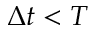<formula> <loc_0><loc_0><loc_500><loc_500>\Delta t < T</formula> 